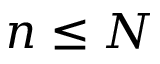Convert formula to latex. <formula><loc_0><loc_0><loc_500><loc_500>n \leq N</formula> 